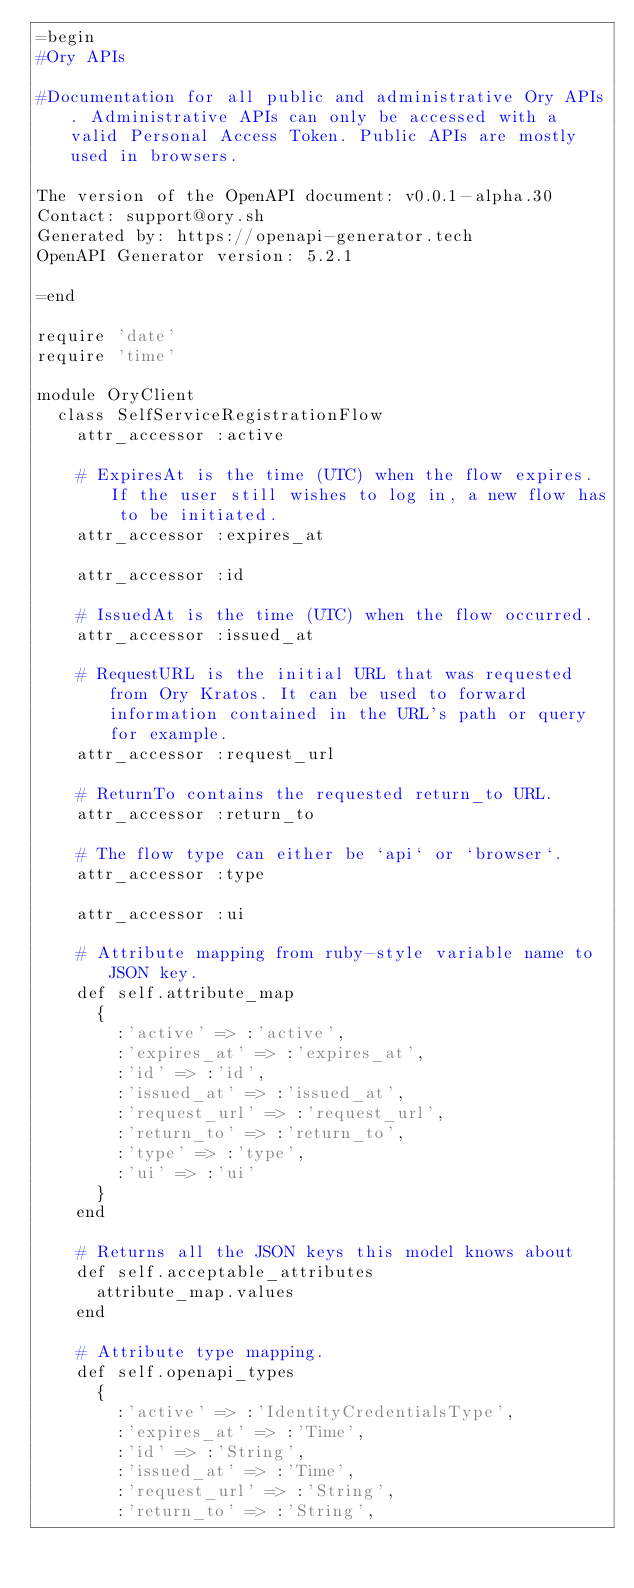<code> <loc_0><loc_0><loc_500><loc_500><_Ruby_>=begin
#Ory APIs

#Documentation for all public and administrative Ory APIs. Administrative APIs can only be accessed with a valid Personal Access Token. Public APIs are mostly used in browsers. 

The version of the OpenAPI document: v0.0.1-alpha.30
Contact: support@ory.sh
Generated by: https://openapi-generator.tech
OpenAPI Generator version: 5.2.1

=end

require 'date'
require 'time'

module OryClient
  class SelfServiceRegistrationFlow
    attr_accessor :active

    # ExpiresAt is the time (UTC) when the flow expires. If the user still wishes to log in, a new flow has to be initiated.
    attr_accessor :expires_at

    attr_accessor :id

    # IssuedAt is the time (UTC) when the flow occurred.
    attr_accessor :issued_at

    # RequestURL is the initial URL that was requested from Ory Kratos. It can be used to forward information contained in the URL's path or query for example.
    attr_accessor :request_url

    # ReturnTo contains the requested return_to URL.
    attr_accessor :return_to

    # The flow type can either be `api` or `browser`.
    attr_accessor :type

    attr_accessor :ui

    # Attribute mapping from ruby-style variable name to JSON key.
    def self.attribute_map
      {
        :'active' => :'active',
        :'expires_at' => :'expires_at',
        :'id' => :'id',
        :'issued_at' => :'issued_at',
        :'request_url' => :'request_url',
        :'return_to' => :'return_to',
        :'type' => :'type',
        :'ui' => :'ui'
      }
    end

    # Returns all the JSON keys this model knows about
    def self.acceptable_attributes
      attribute_map.values
    end

    # Attribute type mapping.
    def self.openapi_types
      {
        :'active' => :'IdentityCredentialsType',
        :'expires_at' => :'Time',
        :'id' => :'String',
        :'issued_at' => :'Time',
        :'request_url' => :'String',
        :'return_to' => :'String',</code> 